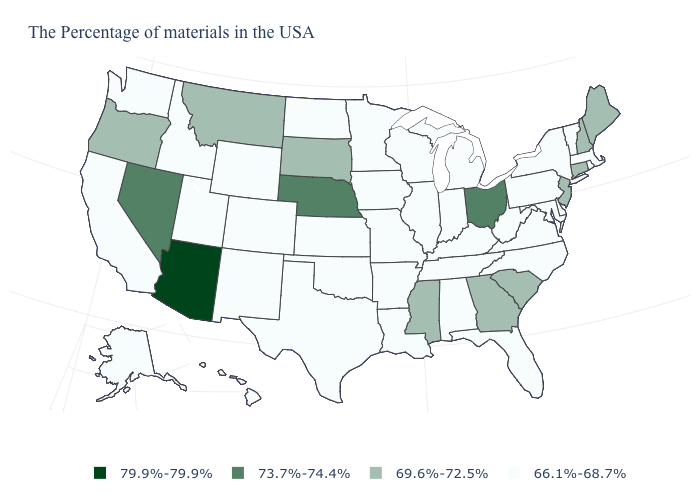Does the map have missing data?
Give a very brief answer. No. What is the value of Mississippi?
Short answer required. 69.6%-72.5%. What is the value of Colorado?
Keep it brief. 66.1%-68.7%. What is the value of New Mexico?
Keep it brief. 66.1%-68.7%. What is the lowest value in states that border New York?
Quick response, please. 66.1%-68.7%. What is the value of Colorado?
Give a very brief answer. 66.1%-68.7%. Which states hav the highest value in the Northeast?
Short answer required. Maine, New Hampshire, Connecticut, New Jersey. What is the highest value in the USA?
Keep it brief. 79.9%-79.9%. Does Iowa have the lowest value in the MidWest?
Concise answer only. Yes. Name the states that have a value in the range 66.1%-68.7%?
Quick response, please. Massachusetts, Rhode Island, Vermont, New York, Delaware, Maryland, Pennsylvania, Virginia, North Carolina, West Virginia, Florida, Michigan, Kentucky, Indiana, Alabama, Tennessee, Wisconsin, Illinois, Louisiana, Missouri, Arkansas, Minnesota, Iowa, Kansas, Oklahoma, Texas, North Dakota, Wyoming, Colorado, New Mexico, Utah, Idaho, California, Washington, Alaska, Hawaii. Does the map have missing data?
Be succinct. No. What is the value of South Carolina?
Quick response, please. 69.6%-72.5%. Name the states that have a value in the range 73.7%-74.4%?
Write a very short answer. Ohio, Nebraska, Nevada. Which states have the highest value in the USA?
Give a very brief answer. Arizona. Among the states that border California , does Arizona have the highest value?
Be succinct. Yes. 